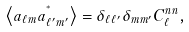<formula> <loc_0><loc_0><loc_500><loc_500>\left < a _ { \ell m } a ^ { ^ { * } } _ { \ell ^ { \prime } m ^ { \prime } } \right > = \delta _ { \ell \ell ^ { \prime } } \delta _ { m m ^ { \prime } } C _ { \ell } ^ { n n } ,</formula> 